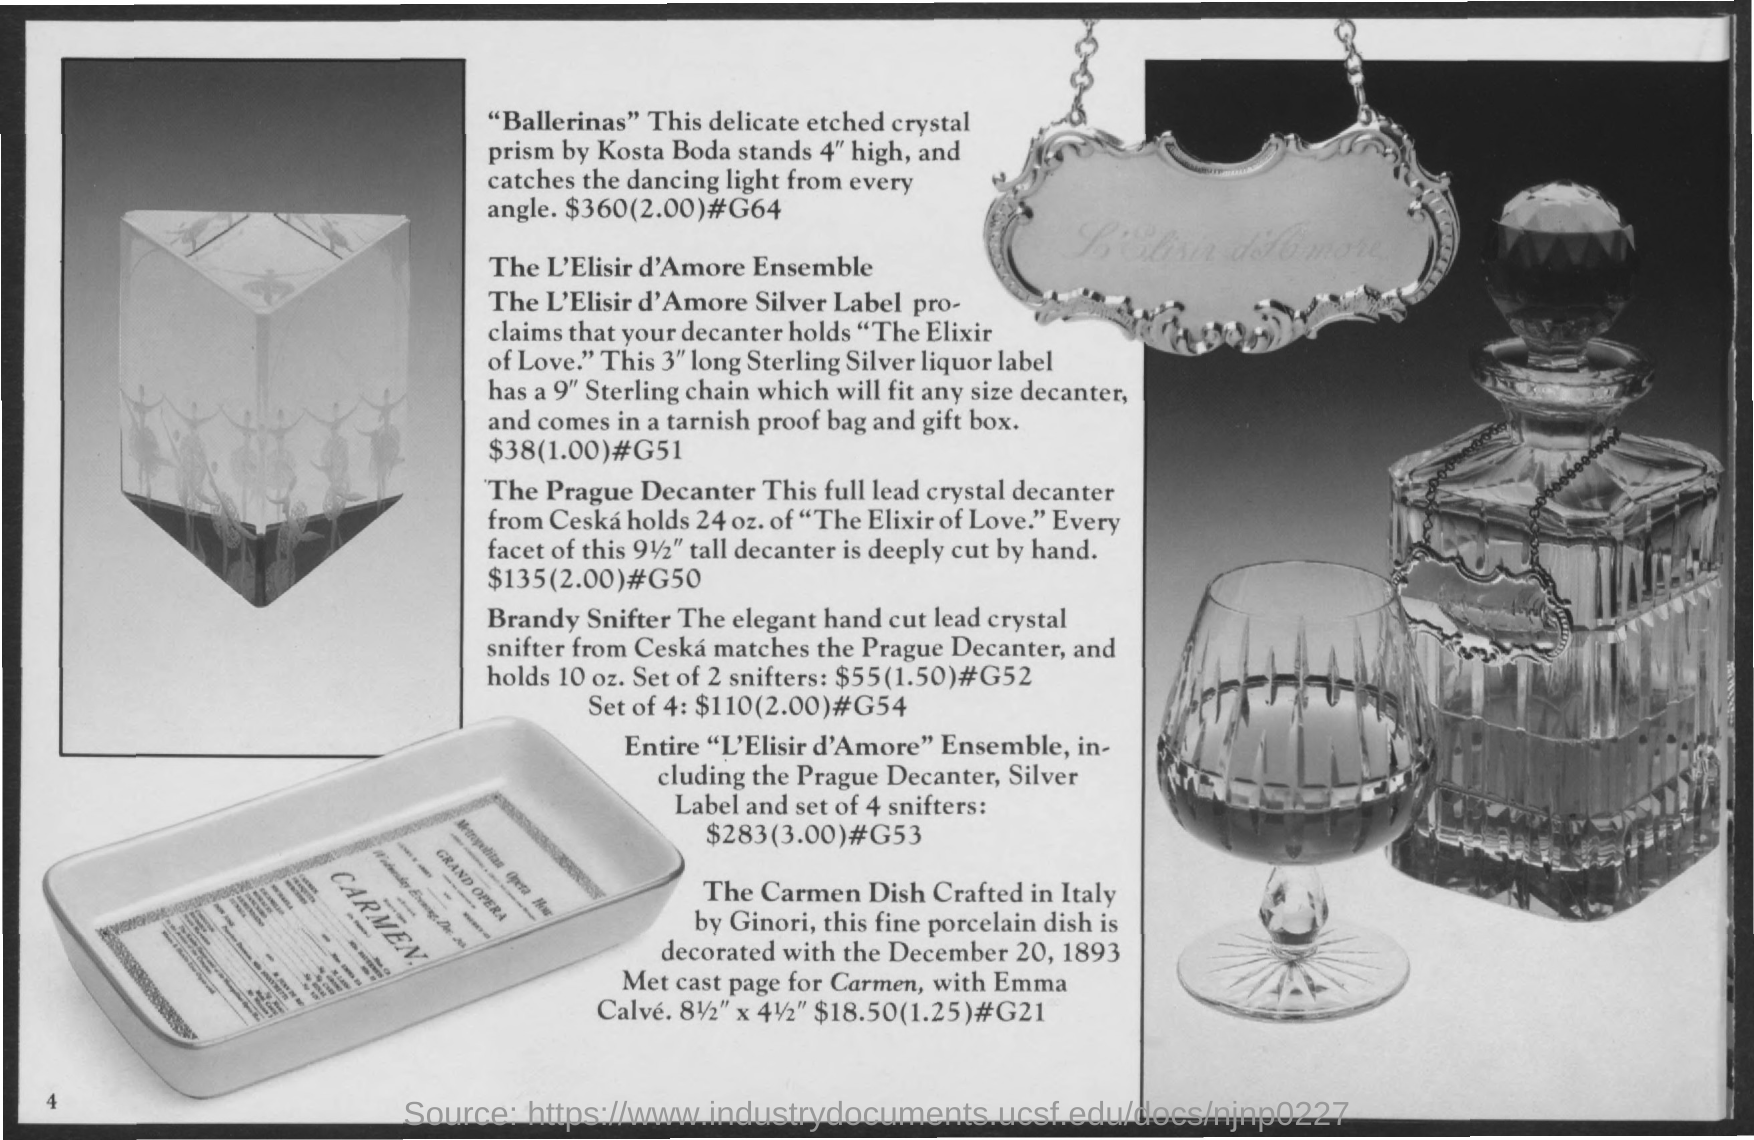What is the cost of "Ballerinas"?
Keep it short and to the point. $360. What is the cost of "The Prague Decanter"?
Ensure brevity in your answer.  $135. 